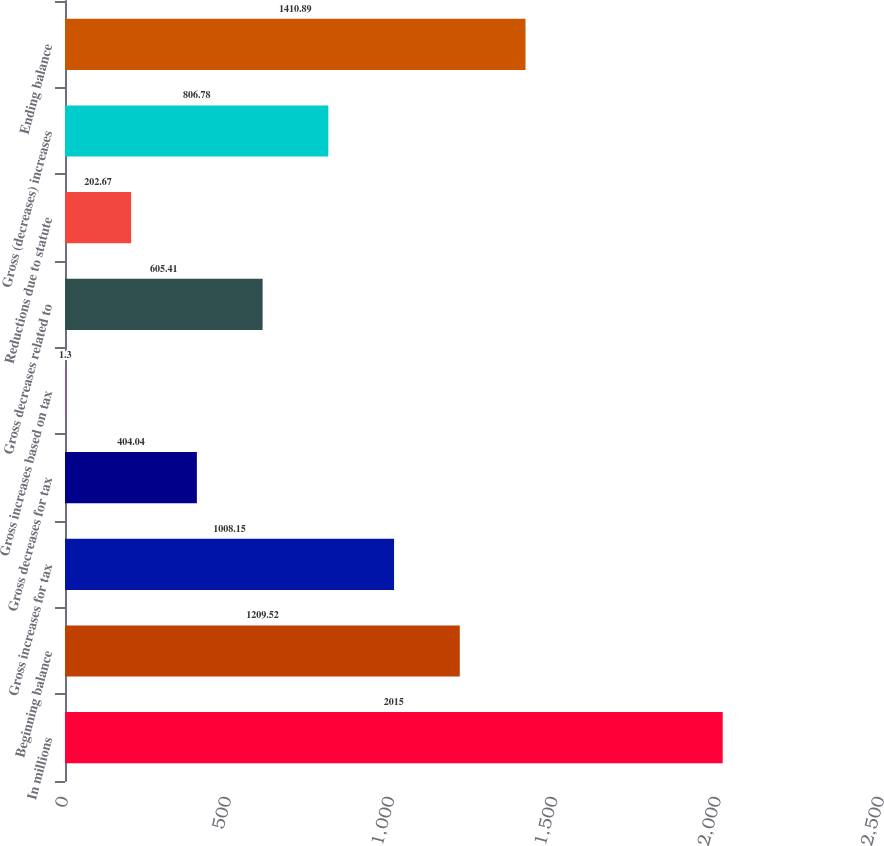Convert chart to OTSL. <chart><loc_0><loc_0><loc_500><loc_500><bar_chart><fcel>In millions<fcel>Beginning balance<fcel>Gross increases for tax<fcel>Gross decreases for tax<fcel>Gross increases based on tax<fcel>Gross decreases related to<fcel>Reductions due to statute<fcel>Gross (decreases) increases<fcel>Ending balance<nl><fcel>2015<fcel>1209.52<fcel>1008.15<fcel>404.04<fcel>1.3<fcel>605.41<fcel>202.67<fcel>806.78<fcel>1410.89<nl></chart> 